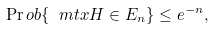<formula> <loc_0><loc_0><loc_500><loc_500>\Pr o b \{ \ m t x { H } \in E _ { n } \} \leq e ^ { - n } ,</formula> 